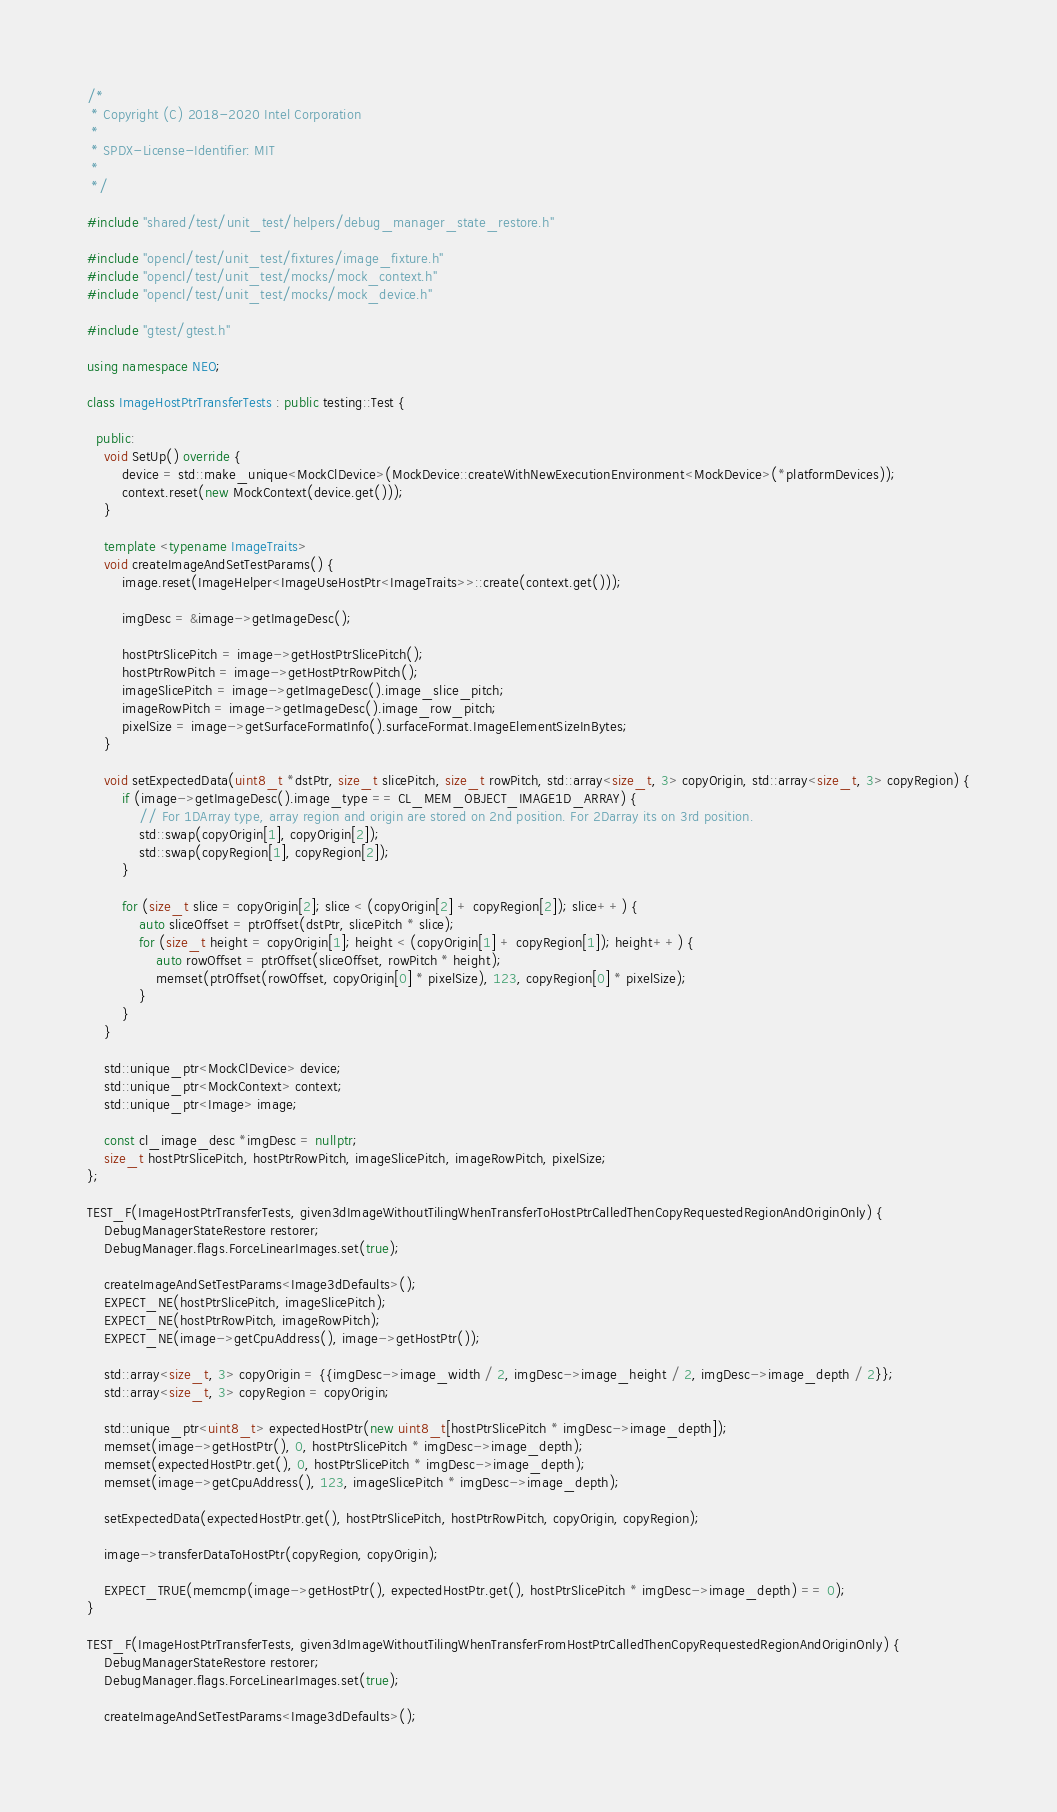Convert code to text. <code><loc_0><loc_0><loc_500><loc_500><_C++_>/*
 * Copyright (C) 2018-2020 Intel Corporation
 *
 * SPDX-License-Identifier: MIT
 *
 */

#include "shared/test/unit_test/helpers/debug_manager_state_restore.h"

#include "opencl/test/unit_test/fixtures/image_fixture.h"
#include "opencl/test/unit_test/mocks/mock_context.h"
#include "opencl/test/unit_test/mocks/mock_device.h"

#include "gtest/gtest.h"

using namespace NEO;

class ImageHostPtrTransferTests : public testing::Test {

  public:
    void SetUp() override {
        device = std::make_unique<MockClDevice>(MockDevice::createWithNewExecutionEnvironment<MockDevice>(*platformDevices));
        context.reset(new MockContext(device.get()));
    }

    template <typename ImageTraits>
    void createImageAndSetTestParams() {
        image.reset(ImageHelper<ImageUseHostPtr<ImageTraits>>::create(context.get()));

        imgDesc = &image->getImageDesc();

        hostPtrSlicePitch = image->getHostPtrSlicePitch();
        hostPtrRowPitch = image->getHostPtrRowPitch();
        imageSlicePitch = image->getImageDesc().image_slice_pitch;
        imageRowPitch = image->getImageDesc().image_row_pitch;
        pixelSize = image->getSurfaceFormatInfo().surfaceFormat.ImageElementSizeInBytes;
    }

    void setExpectedData(uint8_t *dstPtr, size_t slicePitch, size_t rowPitch, std::array<size_t, 3> copyOrigin, std::array<size_t, 3> copyRegion) {
        if (image->getImageDesc().image_type == CL_MEM_OBJECT_IMAGE1D_ARRAY) {
            // For 1DArray type, array region and origin are stored on 2nd position. For 2Darray its on 3rd position.
            std::swap(copyOrigin[1], copyOrigin[2]);
            std::swap(copyRegion[1], copyRegion[2]);
        }

        for (size_t slice = copyOrigin[2]; slice < (copyOrigin[2] + copyRegion[2]); slice++) {
            auto sliceOffset = ptrOffset(dstPtr, slicePitch * slice);
            for (size_t height = copyOrigin[1]; height < (copyOrigin[1] + copyRegion[1]); height++) {
                auto rowOffset = ptrOffset(sliceOffset, rowPitch * height);
                memset(ptrOffset(rowOffset, copyOrigin[0] * pixelSize), 123, copyRegion[0] * pixelSize);
            }
        }
    }

    std::unique_ptr<MockClDevice> device;
    std::unique_ptr<MockContext> context;
    std::unique_ptr<Image> image;

    const cl_image_desc *imgDesc = nullptr;
    size_t hostPtrSlicePitch, hostPtrRowPitch, imageSlicePitch, imageRowPitch, pixelSize;
};

TEST_F(ImageHostPtrTransferTests, given3dImageWithoutTilingWhenTransferToHostPtrCalledThenCopyRequestedRegionAndOriginOnly) {
    DebugManagerStateRestore restorer;
    DebugManager.flags.ForceLinearImages.set(true);

    createImageAndSetTestParams<Image3dDefaults>();
    EXPECT_NE(hostPtrSlicePitch, imageSlicePitch);
    EXPECT_NE(hostPtrRowPitch, imageRowPitch);
    EXPECT_NE(image->getCpuAddress(), image->getHostPtr());

    std::array<size_t, 3> copyOrigin = {{imgDesc->image_width / 2, imgDesc->image_height / 2, imgDesc->image_depth / 2}};
    std::array<size_t, 3> copyRegion = copyOrigin;

    std::unique_ptr<uint8_t> expectedHostPtr(new uint8_t[hostPtrSlicePitch * imgDesc->image_depth]);
    memset(image->getHostPtr(), 0, hostPtrSlicePitch * imgDesc->image_depth);
    memset(expectedHostPtr.get(), 0, hostPtrSlicePitch * imgDesc->image_depth);
    memset(image->getCpuAddress(), 123, imageSlicePitch * imgDesc->image_depth);

    setExpectedData(expectedHostPtr.get(), hostPtrSlicePitch, hostPtrRowPitch, copyOrigin, copyRegion);

    image->transferDataToHostPtr(copyRegion, copyOrigin);

    EXPECT_TRUE(memcmp(image->getHostPtr(), expectedHostPtr.get(), hostPtrSlicePitch * imgDesc->image_depth) == 0);
}

TEST_F(ImageHostPtrTransferTests, given3dImageWithoutTilingWhenTransferFromHostPtrCalledThenCopyRequestedRegionAndOriginOnly) {
    DebugManagerStateRestore restorer;
    DebugManager.flags.ForceLinearImages.set(true);

    createImageAndSetTestParams<Image3dDefaults>();</code> 